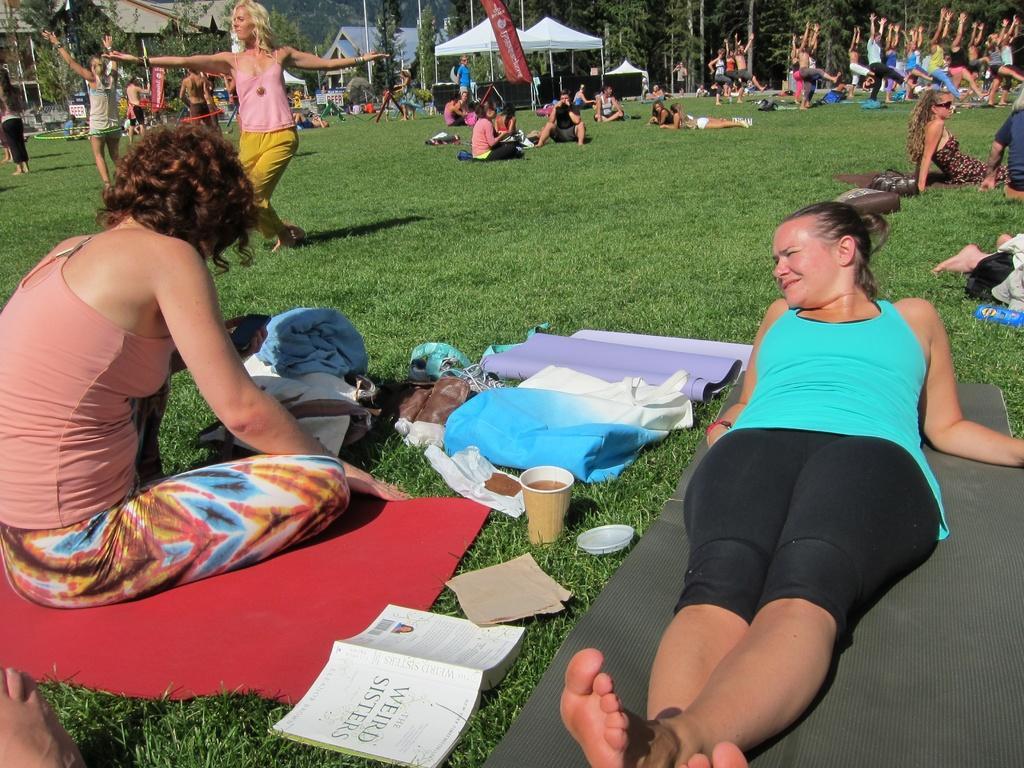In one or two sentences, can you explain what this image depicts? In the foreground of this image, there on the right, there is a woman lying on a mat which is on the grass. Beside her, there are mats, glass, cap, paper, book, a woman sitting on the mat and few bags. In the background, there are persons doing exercise on the grass, few are sitting and lying, few tents, flag, houses and the trees. 